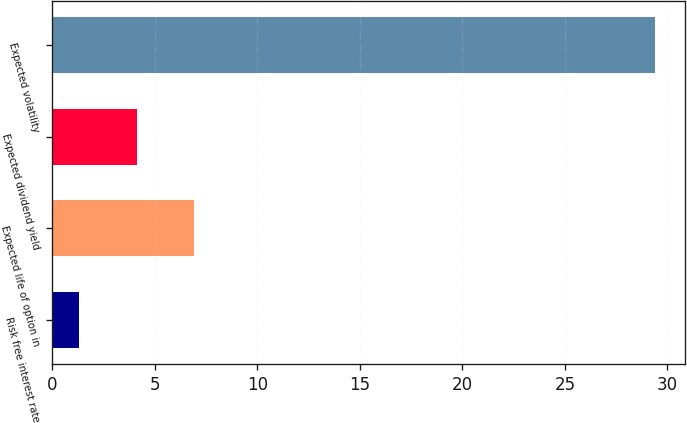Convert chart. <chart><loc_0><loc_0><loc_500><loc_500><bar_chart><fcel>Risk free interest rate<fcel>Expected life of option in<fcel>Expected dividend yield<fcel>Expected volatility<nl><fcel>1.3<fcel>6.92<fcel>4.11<fcel>29.4<nl></chart> 